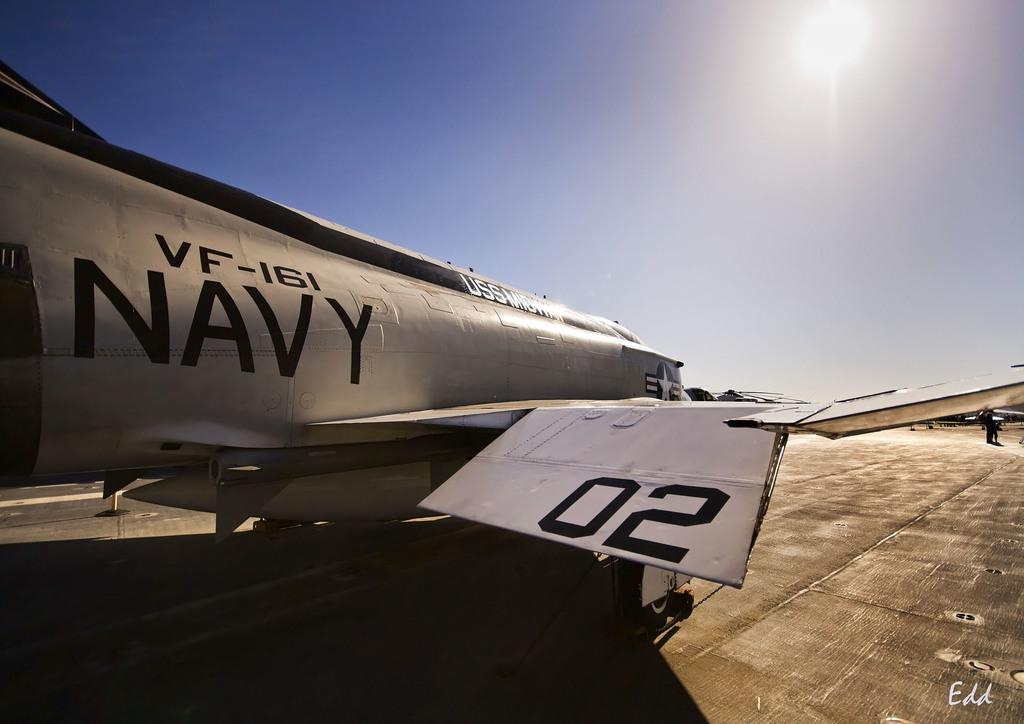<image>
Provide a brief description of the given image. A plane reads "VF-161 NAVY" on the side. 